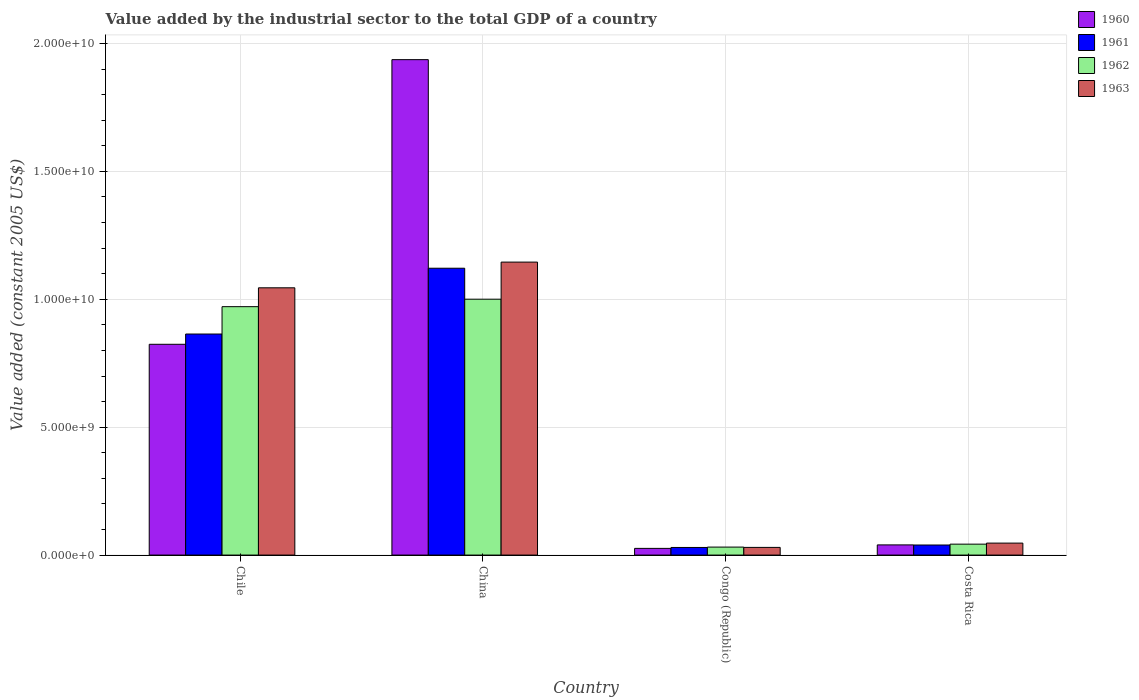How many different coloured bars are there?
Your response must be concise. 4. How many bars are there on the 3rd tick from the left?
Keep it short and to the point. 4. What is the label of the 1st group of bars from the left?
Ensure brevity in your answer.  Chile. In how many cases, is the number of bars for a given country not equal to the number of legend labels?
Offer a terse response. 0. What is the value added by the industrial sector in 1960 in Congo (Republic)?
Keep it short and to the point. 2.61e+08. Across all countries, what is the maximum value added by the industrial sector in 1960?
Provide a succinct answer. 1.94e+1. Across all countries, what is the minimum value added by the industrial sector in 1960?
Your answer should be compact. 2.61e+08. In which country was the value added by the industrial sector in 1961 minimum?
Your answer should be compact. Congo (Republic). What is the total value added by the industrial sector in 1960 in the graph?
Offer a very short reply. 2.83e+1. What is the difference between the value added by the industrial sector in 1961 in China and that in Congo (Republic)?
Make the answer very short. 1.09e+1. What is the difference between the value added by the industrial sector in 1961 in Congo (Republic) and the value added by the industrial sector in 1963 in Chile?
Your answer should be very brief. -1.02e+1. What is the average value added by the industrial sector in 1960 per country?
Offer a very short reply. 7.07e+09. What is the difference between the value added by the industrial sector of/in 1962 and value added by the industrial sector of/in 1960 in Congo (Republic)?
Provide a short and direct response. 5.10e+07. What is the ratio of the value added by the industrial sector in 1960 in China to that in Congo (Republic)?
Provide a succinct answer. 74.09. Is the value added by the industrial sector in 1962 in Chile less than that in Costa Rica?
Provide a short and direct response. No. Is the difference between the value added by the industrial sector in 1962 in Chile and Costa Rica greater than the difference between the value added by the industrial sector in 1960 in Chile and Costa Rica?
Your response must be concise. Yes. What is the difference between the highest and the second highest value added by the industrial sector in 1961?
Make the answer very short. -8.25e+09. What is the difference between the highest and the lowest value added by the industrial sector in 1961?
Offer a very short reply. 1.09e+1. In how many countries, is the value added by the industrial sector in 1963 greater than the average value added by the industrial sector in 1963 taken over all countries?
Offer a very short reply. 2. What does the 4th bar from the left in China represents?
Make the answer very short. 1963. What does the 4th bar from the right in Chile represents?
Your answer should be compact. 1960. Are all the bars in the graph horizontal?
Your response must be concise. No. Does the graph contain any zero values?
Keep it short and to the point. No. How many legend labels are there?
Offer a very short reply. 4. What is the title of the graph?
Make the answer very short. Value added by the industrial sector to the total GDP of a country. What is the label or title of the Y-axis?
Make the answer very short. Value added (constant 2005 US$). What is the Value added (constant 2005 US$) in 1960 in Chile?
Your response must be concise. 8.24e+09. What is the Value added (constant 2005 US$) of 1961 in Chile?
Your answer should be compact. 8.64e+09. What is the Value added (constant 2005 US$) in 1962 in Chile?
Your answer should be very brief. 9.71e+09. What is the Value added (constant 2005 US$) in 1963 in Chile?
Offer a very short reply. 1.04e+1. What is the Value added (constant 2005 US$) in 1960 in China?
Offer a terse response. 1.94e+1. What is the Value added (constant 2005 US$) of 1961 in China?
Provide a short and direct response. 1.12e+1. What is the Value added (constant 2005 US$) of 1962 in China?
Ensure brevity in your answer.  1.00e+1. What is the Value added (constant 2005 US$) of 1963 in China?
Provide a short and direct response. 1.15e+1. What is the Value added (constant 2005 US$) in 1960 in Congo (Republic)?
Your answer should be compact. 2.61e+08. What is the Value added (constant 2005 US$) in 1961 in Congo (Republic)?
Your answer should be compact. 2.98e+08. What is the Value added (constant 2005 US$) of 1962 in Congo (Republic)?
Keep it short and to the point. 3.12e+08. What is the Value added (constant 2005 US$) in 1963 in Congo (Republic)?
Provide a short and direct response. 3.00e+08. What is the Value added (constant 2005 US$) of 1960 in Costa Rica?
Your answer should be compact. 3.98e+08. What is the Value added (constant 2005 US$) in 1961 in Costa Rica?
Give a very brief answer. 3.94e+08. What is the Value added (constant 2005 US$) in 1962 in Costa Rica?
Give a very brief answer. 4.27e+08. What is the Value added (constant 2005 US$) in 1963 in Costa Rica?
Your response must be concise. 4.68e+08. Across all countries, what is the maximum Value added (constant 2005 US$) of 1960?
Keep it short and to the point. 1.94e+1. Across all countries, what is the maximum Value added (constant 2005 US$) of 1961?
Your answer should be compact. 1.12e+1. Across all countries, what is the maximum Value added (constant 2005 US$) of 1962?
Make the answer very short. 1.00e+1. Across all countries, what is the maximum Value added (constant 2005 US$) in 1963?
Your response must be concise. 1.15e+1. Across all countries, what is the minimum Value added (constant 2005 US$) of 1960?
Your response must be concise. 2.61e+08. Across all countries, what is the minimum Value added (constant 2005 US$) of 1961?
Your answer should be very brief. 2.98e+08. Across all countries, what is the minimum Value added (constant 2005 US$) of 1962?
Ensure brevity in your answer.  3.12e+08. Across all countries, what is the minimum Value added (constant 2005 US$) of 1963?
Your answer should be very brief. 3.00e+08. What is the total Value added (constant 2005 US$) of 1960 in the graph?
Make the answer very short. 2.83e+1. What is the total Value added (constant 2005 US$) of 1961 in the graph?
Offer a terse response. 2.05e+1. What is the total Value added (constant 2005 US$) of 1962 in the graph?
Offer a very short reply. 2.05e+1. What is the total Value added (constant 2005 US$) in 1963 in the graph?
Provide a short and direct response. 2.27e+1. What is the difference between the Value added (constant 2005 US$) of 1960 in Chile and that in China?
Your answer should be compact. -1.11e+1. What is the difference between the Value added (constant 2005 US$) in 1961 in Chile and that in China?
Your answer should be very brief. -2.57e+09. What is the difference between the Value added (constant 2005 US$) of 1962 in Chile and that in China?
Offer a terse response. -2.92e+08. What is the difference between the Value added (constant 2005 US$) of 1963 in Chile and that in China?
Make the answer very short. -1.01e+09. What is the difference between the Value added (constant 2005 US$) in 1960 in Chile and that in Congo (Republic)?
Provide a succinct answer. 7.98e+09. What is the difference between the Value added (constant 2005 US$) in 1961 in Chile and that in Congo (Republic)?
Make the answer very short. 8.34e+09. What is the difference between the Value added (constant 2005 US$) in 1962 in Chile and that in Congo (Republic)?
Ensure brevity in your answer.  9.40e+09. What is the difference between the Value added (constant 2005 US$) in 1963 in Chile and that in Congo (Republic)?
Ensure brevity in your answer.  1.01e+1. What is the difference between the Value added (constant 2005 US$) of 1960 in Chile and that in Costa Rica?
Provide a succinct answer. 7.84e+09. What is the difference between the Value added (constant 2005 US$) in 1961 in Chile and that in Costa Rica?
Ensure brevity in your answer.  8.25e+09. What is the difference between the Value added (constant 2005 US$) in 1962 in Chile and that in Costa Rica?
Your response must be concise. 9.28e+09. What is the difference between the Value added (constant 2005 US$) in 1963 in Chile and that in Costa Rica?
Offer a very short reply. 9.98e+09. What is the difference between the Value added (constant 2005 US$) of 1960 in China and that in Congo (Republic)?
Provide a short and direct response. 1.91e+1. What is the difference between the Value added (constant 2005 US$) in 1961 in China and that in Congo (Republic)?
Your answer should be very brief. 1.09e+1. What is the difference between the Value added (constant 2005 US$) in 1962 in China and that in Congo (Republic)?
Your response must be concise. 9.69e+09. What is the difference between the Value added (constant 2005 US$) of 1963 in China and that in Congo (Republic)?
Your answer should be compact. 1.12e+1. What is the difference between the Value added (constant 2005 US$) of 1960 in China and that in Costa Rica?
Give a very brief answer. 1.90e+1. What is the difference between the Value added (constant 2005 US$) in 1961 in China and that in Costa Rica?
Offer a very short reply. 1.08e+1. What is the difference between the Value added (constant 2005 US$) in 1962 in China and that in Costa Rica?
Make the answer very short. 9.58e+09. What is the difference between the Value added (constant 2005 US$) in 1963 in China and that in Costa Rica?
Give a very brief answer. 1.10e+1. What is the difference between the Value added (constant 2005 US$) in 1960 in Congo (Republic) and that in Costa Rica?
Make the answer very short. -1.36e+08. What is the difference between the Value added (constant 2005 US$) of 1961 in Congo (Republic) and that in Costa Rica?
Keep it short and to the point. -9.59e+07. What is the difference between the Value added (constant 2005 US$) of 1962 in Congo (Republic) and that in Costa Rica?
Your answer should be compact. -1.14e+08. What is the difference between the Value added (constant 2005 US$) of 1963 in Congo (Republic) and that in Costa Rica?
Ensure brevity in your answer.  -1.68e+08. What is the difference between the Value added (constant 2005 US$) in 1960 in Chile and the Value added (constant 2005 US$) in 1961 in China?
Your answer should be compact. -2.97e+09. What is the difference between the Value added (constant 2005 US$) of 1960 in Chile and the Value added (constant 2005 US$) of 1962 in China?
Your response must be concise. -1.76e+09. What is the difference between the Value added (constant 2005 US$) in 1960 in Chile and the Value added (constant 2005 US$) in 1963 in China?
Give a very brief answer. -3.21e+09. What is the difference between the Value added (constant 2005 US$) of 1961 in Chile and the Value added (constant 2005 US$) of 1962 in China?
Provide a succinct answer. -1.36e+09. What is the difference between the Value added (constant 2005 US$) in 1961 in Chile and the Value added (constant 2005 US$) in 1963 in China?
Provide a succinct answer. -2.81e+09. What is the difference between the Value added (constant 2005 US$) in 1962 in Chile and the Value added (constant 2005 US$) in 1963 in China?
Offer a very short reply. -1.74e+09. What is the difference between the Value added (constant 2005 US$) of 1960 in Chile and the Value added (constant 2005 US$) of 1961 in Congo (Republic)?
Provide a short and direct response. 7.94e+09. What is the difference between the Value added (constant 2005 US$) in 1960 in Chile and the Value added (constant 2005 US$) in 1962 in Congo (Republic)?
Your answer should be very brief. 7.93e+09. What is the difference between the Value added (constant 2005 US$) of 1960 in Chile and the Value added (constant 2005 US$) of 1963 in Congo (Republic)?
Provide a short and direct response. 7.94e+09. What is the difference between the Value added (constant 2005 US$) in 1961 in Chile and the Value added (constant 2005 US$) in 1962 in Congo (Republic)?
Provide a succinct answer. 8.33e+09. What is the difference between the Value added (constant 2005 US$) in 1961 in Chile and the Value added (constant 2005 US$) in 1963 in Congo (Republic)?
Your answer should be very brief. 8.34e+09. What is the difference between the Value added (constant 2005 US$) of 1962 in Chile and the Value added (constant 2005 US$) of 1963 in Congo (Republic)?
Provide a succinct answer. 9.41e+09. What is the difference between the Value added (constant 2005 US$) of 1960 in Chile and the Value added (constant 2005 US$) of 1961 in Costa Rica?
Your answer should be very brief. 7.85e+09. What is the difference between the Value added (constant 2005 US$) in 1960 in Chile and the Value added (constant 2005 US$) in 1962 in Costa Rica?
Offer a very short reply. 7.81e+09. What is the difference between the Value added (constant 2005 US$) of 1960 in Chile and the Value added (constant 2005 US$) of 1963 in Costa Rica?
Offer a very short reply. 7.77e+09. What is the difference between the Value added (constant 2005 US$) in 1961 in Chile and the Value added (constant 2005 US$) in 1962 in Costa Rica?
Offer a terse response. 8.21e+09. What is the difference between the Value added (constant 2005 US$) in 1961 in Chile and the Value added (constant 2005 US$) in 1963 in Costa Rica?
Provide a short and direct response. 8.17e+09. What is the difference between the Value added (constant 2005 US$) in 1962 in Chile and the Value added (constant 2005 US$) in 1963 in Costa Rica?
Provide a short and direct response. 9.24e+09. What is the difference between the Value added (constant 2005 US$) in 1960 in China and the Value added (constant 2005 US$) in 1961 in Congo (Republic)?
Offer a very short reply. 1.91e+1. What is the difference between the Value added (constant 2005 US$) of 1960 in China and the Value added (constant 2005 US$) of 1962 in Congo (Republic)?
Keep it short and to the point. 1.91e+1. What is the difference between the Value added (constant 2005 US$) of 1960 in China and the Value added (constant 2005 US$) of 1963 in Congo (Republic)?
Give a very brief answer. 1.91e+1. What is the difference between the Value added (constant 2005 US$) in 1961 in China and the Value added (constant 2005 US$) in 1962 in Congo (Republic)?
Provide a succinct answer. 1.09e+1. What is the difference between the Value added (constant 2005 US$) in 1961 in China and the Value added (constant 2005 US$) in 1963 in Congo (Republic)?
Make the answer very short. 1.09e+1. What is the difference between the Value added (constant 2005 US$) of 1962 in China and the Value added (constant 2005 US$) of 1963 in Congo (Republic)?
Offer a very short reply. 9.70e+09. What is the difference between the Value added (constant 2005 US$) in 1960 in China and the Value added (constant 2005 US$) in 1961 in Costa Rica?
Make the answer very short. 1.90e+1. What is the difference between the Value added (constant 2005 US$) of 1960 in China and the Value added (constant 2005 US$) of 1962 in Costa Rica?
Offer a terse response. 1.89e+1. What is the difference between the Value added (constant 2005 US$) in 1960 in China and the Value added (constant 2005 US$) in 1963 in Costa Rica?
Provide a succinct answer. 1.89e+1. What is the difference between the Value added (constant 2005 US$) in 1961 in China and the Value added (constant 2005 US$) in 1962 in Costa Rica?
Make the answer very short. 1.08e+1. What is the difference between the Value added (constant 2005 US$) in 1961 in China and the Value added (constant 2005 US$) in 1963 in Costa Rica?
Offer a terse response. 1.07e+1. What is the difference between the Value added (constant 2005 US$) in 1962 in China and the Value added (constant 2005 US$) in 1963 in Costa Rica?
Offer a terse response. 9.53e+09. What is the difference between the Value added (constant 2005 US$) of 1960 in Congo (Republic) and the Value added (constant 2005 US$) of 1961 in Costa Rica?
Make the answer very short. -1.32e+08. What is the difference between the Value added (constant 2005 US$) in 1960 in Congo (Republic) and the Value added (constant 2005 US$) in 1962 in Costa Rica?
Keep it short and to the point. -1.65e+08. What is the difference between the Value added (constant 2005 US$) in 1960 in Congo (Republic) and the Value added (constant 2005 US$) in 1963 in Costa Rica?
Offer a terse response. -2.07e+08. What is the difference between the Value added (constant 2005 US$) in 1961 in Congo (Republic) and the Value added (constant 2005 US$) in 1962 in Costa Rica?
Provide a short and direct response. -1.29e+08. What is the difference between the Value added (constant 2005 US$) of 1961 in Congo (Republic) and the Value added (constant 2005 US$) of 1963 in Costa Rica?
Provide a short and direct response. -1.70e+08. What is the difference between the Value added (constant 2005 US$) of 1962 in Congo (Republic) and the Value added (constant 2005 US$) of 1963 in Costa Rica?
Keep it short and to the point. -1.56e+08. What is the average Value added (constant 2005 US$) in 1960 per country?
Offer a very short reply. 7.07e+09. What is the average Value added (constant 2005 US$) of 1961 per country?
Make the answer very short. 5.14e+09. What is the average Value added (constant 2005 US$) in 1962 per country?
Offer a terse response. 5.11e+09. What is the average Value added (constant 2005 US$) of 1963 per country?
Your response must be concise. 5.67e+09. What is the difference between the Value added (constant 2005 US$) in 1960 and Value added (constant 2005 US$) in 1961 in Chile?
Provide a short and direct response. -4.01e+08. What is the difference between the Value added (constant 2005 US$) of 1960 and Value added (constant 2005 US$) of 1962 in Chile?
Provide a succinct answer. -1.47e+09. What is the difference between the Value added (constant 2005 US$) in 1960 and Value added (constant 2005 US$) in 1963 in Chile?
Your response must be concise. -2.21e+09. What is the difference between the Value added (constant 2005 US$) in 1961 and Value added (constant 2005 US$) in 1962 in Chile?
Provide a short and direct response. -1.07e+09. What is the difference between the Value added (constant 2005 US$) in 1961 and Value added (constant 2005 US$) in 1963 in Chile?
Your answer should be very brief. -1.81e+09. What is the difference between the Value added (constant 2005 US$) in 1962 and Value added (constant 2005 US$) in 1963 in Chile?
Offer a terse response. -7.37e+08. What is the difference between the Value added (constant 2005 US$) of 1960 and Value added (constant 2005 US$) of 1961 in China?
Offer a terse response. 8.15e+09. What is the difference between the Value added (constant 2005 US$) of 1960 and Value added (constant 2005 US$) of 1962 in China?
Ensure brevity in your answer.  9.36e+09. What is the difference between the Value added (constant 2005 US$) in 1960 and Value added (constant 2005 US$) in 1963 in China?
Provide a succinct answer. 7.91e+09. What is the difference between the Value added (constant 2005 US$) in 1961 and Value added (constant 2005 US$) in 1962 in China?
Your answer should be very brief. 1.21e+09. What is the difference between the Value added (constant 2005 US$) in 1961 and Value added (constant 2005 US$) in 1963 in China?
Your answer should be very brief. -2.39e+08. What is the difference between the Value added (constant 2005 US$) in 1962 and Value added (constant 2005 US$) in 1963 in China?
Ensure brevity in your answer.  -1.45e+09. What is the difference between the Value added (constant 2005 US$) in 1960 and Value added (constant 2005 US$) in 1961 in Congo (Republic)?
Keep it short and to the point. -3.63e+07. What is the difference between the Value added (constant 2005 US$) in 1960 and Value added (constant 2005 US$) in 1962 in Congo (Republic)?
Ensure brevity in your answer.  -5.10e+07. What is the difference between the Value added (constant 2005 US$) of 1960 and Value added (constant 2005 US$) of 1963 in Congo (Republic)?
Offer a very short reply. -3.84e+07. What is the difference between the Value added (constant 2005 US$) of 1961 and Value added (constant 2005 US$) of 1962 in Congo (Republic)?
Your response must be concise. -1.47e+07. What is the difference between the Value added (constant 2005 US$) of 1961 and Value added (constant 2005 US$) of 1963 in Congo (Republic)?
Make the answer very short. -2.10e+06. What is the difference between the Value added (constant 2005 US$) in 1962 and Value added (constant 2005 US$) in 1963 in Congo (Republic)?
Provide a succinct answer. 1.26e+07. What is the difference between the Value added (constant 2005 US$) in 1960 and Value added (constant 2005 US$) in 1961 in Costa Rica?
Make the answer very short. 4.19e+06. What is the difference between the Value added (constant 2005 US$) of 1960 and Value added (constant 2005 US$) of 1962 in Costa Rica?
Provide a succinct answer. -2.91e+07. What is the difference between the Value added (constant 2005 US$) of 1960 and Value added (constant 2005 US$) of 1963 in Costa Rica?
Provide a short and direct response. -7.01e+07. What is the difference between the Value added (constant 2005 US$) in 1961 and Value added (constant 2005 US$) in 1962 in Costa Rica?
Offer a very short reply. -3.32e+07. What is the difference between the Value added (constant 2005 US$) of 1961 and Value added (constant 2005 US$) of 1963 in Costa Rica?
Your answer should be compact. -7.43e+07. What is the difference between the Value added (constant 2005 US$) of 1962 and Value added (constant 2005 US$) of 1963 in Costa Rica?
Ensure brevity in your answer.  -4.11e+07. What is the ratio of the Value added (constant 2005 US$) in 1960 in Chile to that in China?
Provide a short and direct response. 0.43. What is the ratio of the Value added (constant 2005 US$) of 1961 in Chile to that in China?
Offer a very short reply. 0.77. What is the ratio of the Value added (constant 2005 US$) in 1962 in Chile to that in China?
Your response must be concise. 0.97. What is the ratio of the Value added (constant 2005 US$) of 1963 in Chile to that in China?
Ensure brevity in your answer.  0.91. What is the ratio of the Value added (constant 2005 US$) of 1960 in Chile to that in Congo (Republic)?
Offer a terse response. 31.52. What is the ratio of the Value added (constant 2005 US$) of 1961 in Chile to that in Congo (Republic)?
Your answer should be very brief. 29.03. What is the ratio of the Value added (constant 2005 US$) of 1962 in Chile to that in Congo (Republic)?
Make the answer very short. 31.09. What is the ratio of the Value added (constant 2005 US$) in 1963 in Chile to that in Congo (Republic)?
Make the answer very short. 34.85. What is the ratio of the Value added (constant 2005 US$) in 1960 in Chile to that in Costa Rica?
Your answer should be very brief. 20.71. What is the ratio of the Value added (constant 2005 US$) in 1961 in Chile to that in Costa Rica?
Your answer should be very brief. 21.95. What is the ratio of the Value added (constant 2005 US$) in 1962 in Chile to that in Costa Rica?
Offer a terse response. 22.75. What is the ratio of the Value added (constant 2005 US$) of 1963 in Chile to that in Costa Rica?
Give a very brief answer. 22.33. What is the ratio of the Value added (constant 2005 US$) in 1960 in China to that in Congo (Republic)?
Ensure brevity in your answer.  74.09. What is the ratio of the Value added (constant 2005 US$) of 1961 in China to that in Congo (Republic)?
Your answer should be very brief. 37.67. What is the ratio of the Value added (constant 2005 US$) of 1962 in China to that in Congo (Republic)?
Make the answer very short. 32.02. What is the ratio of the Value added (constant 2005 US$) in 1963 in China to that in Congo (Republic)?
Your answer should be very brief. 38.21. What is the ratio of the Value added (constant 2005 US$) in 1960 in China to that in Costa Rica?
Ensure brevity in your answer.  48.69. What is the ratio of the Value added (constant 2005 US$) in 1961 in China to that in Costa Rica?
Provide a short and direct response. 28.49. What is the ratio of the Value added (constant 2005 US$) of 1962 in China to that in Costa Rica?
Your answer should be compact. 23.43. What is the ratio of the Value added (constant 2005 US$) in 1963 in China to that in Costa Rica?
Provide a short and direct response. 24.48. What is the ratio of the Value added (constant 2005 US$) in 1960 in Congo (Republic) to that in Costa Rica?
Provide a succinct answer. 0.66. What is the ratio of the Value added (constant 2005 US$) in 1961 in Congo (Republic) to that in Costa Rica?
Your answer should be very brief. 0.76. What is the ratio of the Value added (constant 2005 US$) in 1962 in Congo (Republic) to that in Costa Rica?
Offer a terse response. 0.73. What is the ratio of the Value added (constant 2005 US$) of 1963 in Congo (Republic) to that in Costa Rica?
Offer a terse response. 0.64. What is the difference between the highest and the second highest Value added (constant 2005 US$) of 1960?
Your answer should be very brief. 1.11e+1. What is the difference between the highest and the second highest Value added (constant 2005 US$) in 1961?
Offer a very short reply. 2.57e+09. What is the difference between the highest and the second highest Value added (constant 2005 US$) in 1962?
Make the answer very short. 2.92e+08. What is the difference between the highest and the second highest Value added (constant 2005 US$) of 1963?
Offer a terse response. 1.01e+09. What is the difference between the highest and the lowest Value added (constant 2005 US$) in 1960?
Provide a succinct answer. 1.91e+1. What is the difference between the highest and the lowest Value added (constant 2005 US$) in 1961?
Your answer should be compact. 1.09e+1. What is the difference between the highest and the lowest Value added (constant 2005 US$) of 1962?
Give a very brief answer. 9.69e+09. What is the difference between the highest and the lowest Value added (constant 2005 US$) of 1963?
Provide a short and direct response. 1.12e+1. 